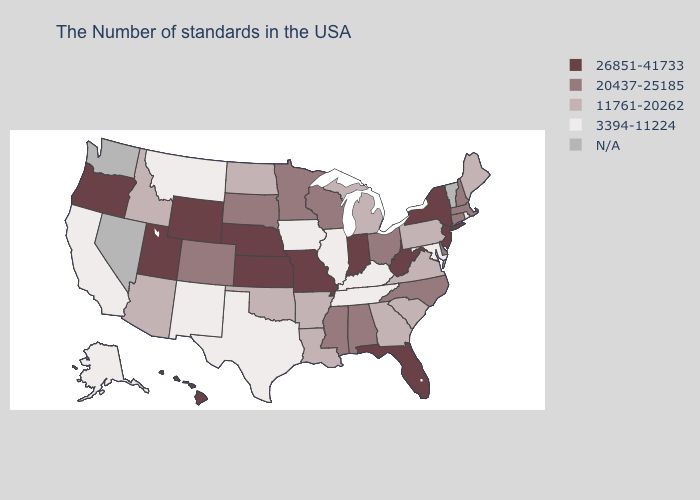Which states have the lowest value in the South?
Short answer required. Maryland, Kentucky, Tennessee, Texas. What is the highest value in states that border Maine?
Write a very short answer. 20437-25185. Name the states that have a value in the range N/A?
Keep it brief. Vermont, Nevada, Washington. Among the states that border Georgia , which have the lowest value?
Quick response, please. Tennessee. Name the states that have a value in the range 20437-25185?
Give a very brief answer. Massachusetts, New Hampshire, Connecticut, Delaware, North Carolina, Ohio, Alabama, Wisconsin, Mississippi, Minnesota, South Dakota, Colorado. Does the first symbol in the legend represent the smallest category?
Quick response, please. No. How many symbols are there in the legend?
Short answer required. 5. Name the states that have a value in the range 20437-25185?
Keep it brief. Massachusetts, New Hampshire, Connecticut, Delaware, North Carolina, Ohio, Alabama, Wisconsin, Mississippi, Minnesota, South Dakota, Colorado. Name the states that have a value in the range 26851-41733?
Keep it brief. New York, New Jersey, West Virginia, Florida, Indiana, Missouri, Kansas, Nebraska, Wyoming, Utah, Oregon, Hawaii. What is the value of North Carolina?
Be succinct. 20437-25185. What is the value of Tennessee?
Concise answer only. 3394-11224. Name the states that have a value in the range 11761-20262?
Short answer required. Maine, Pennsylvania, Virginia, South Carolina, Georgia, Michigan, Louisiana, Arkansas, Oklahoma, North Dakota, Arizona, Idaho. What is the value of Hawaii?
Give a very brief answer. 26851-41733. Among the states that border Colorado , does Wyoming have the highest value?
Short answer required. Yes. 